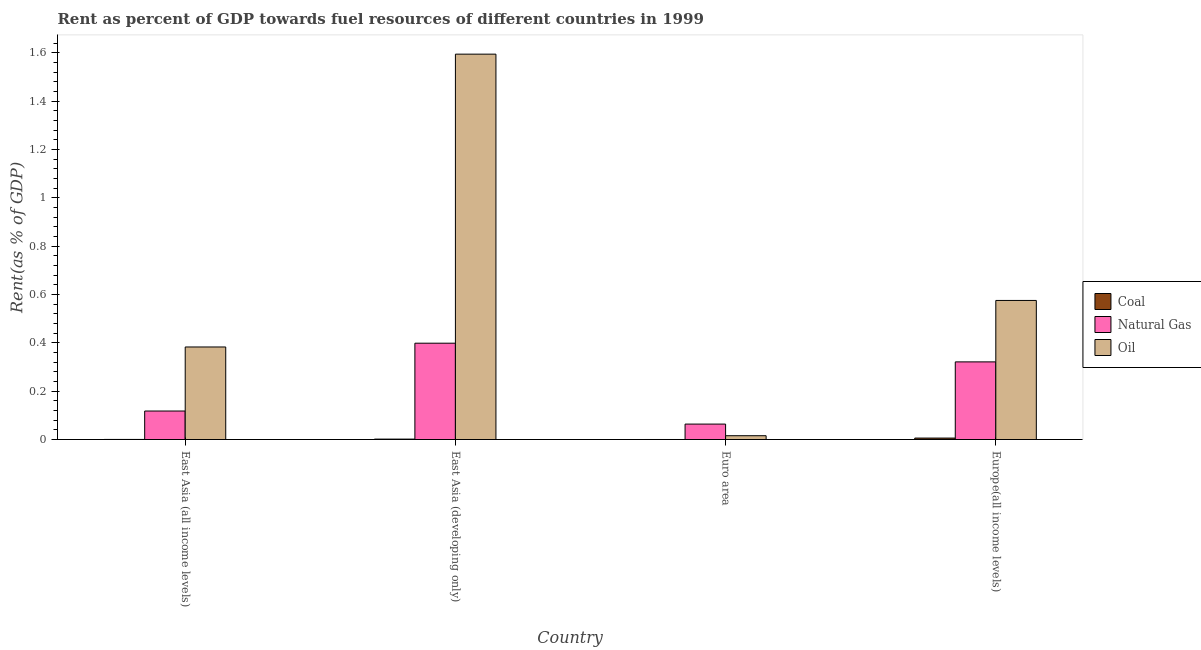How many different coloured bars are there?
Your answer should be compact. 3. How many groups of bars are there?
Your answer should be compact. 4. Are the number of bars per tick equal to the number of legend labels?
Your response must be concise. Yes. Are the number of bars on each tick of the X-axis equal?
Your answer should be very brief. Yes. How many bars are there on the 1st tick from the left?
Provide a short and direct response. 3. How many bars are there on the 3rd tick from the right?
Ensure brevity in your answer.  3. What is the label of the 2nd group of bars from the left?
Offer a terse response. East Asia (developing only). In how many cases, is the number of bars for a given country not equal to the number of legend labels?
Make the answer very short. 0. What is the rent towards oil in Europe(all income levels)?
Your answer should be very brief. 0.58. Across all countries, what is the maximum rent towards natural gas?
Your answer should be very brief. 0.4. Across all countries, what is the minimum rent towards natural gas?
Provide a succinct answer. 0.06. In which country was the rent towards coal maximum?
Keep it short and to the point. Europe(all income levels). In which country was the rent towards oil minimum?
Keep it short and to the point. Euro area. What is the total rent towards natural gas in the graph?
Offer a very short reply. 0.9. What is the difference between the rent towards oil in East Asia (developing only) and that in Euro area?
Your answer should be compact. 1.58. What is the difference between the rent towards coal in Euro area and the rent towards oil in East Asia (developing only)?
Make the answer very short. -1.59. What is the average rent towards oil per country?
Offer a terse response. 0.64. What is the difference between the rent towards natural gas and rent towards oil in East Asia (all income levels)?
Provide a succinct answer. -0.26. What is the ratio of the rent towards coal in East Asia (developing only) to that in Europe(all income levels)?
Offer a very short reply. 0.29. Is the rent towards natural gas in East Asia (developing only) less than that in Europe(all income levels)?
Ensure brevity in your answer.  No. Is the difference between the rent towards oil in Euro area and Europe(all income levels) greater than the difference between the rent towards coal in Euro area and Europe(all income levels)?
Provide a short and direct response. No. What is the difference between the highest and the second highest rent towards oil?
Your answer should be compact. 1.02. What is the difference between the highest and the lowest rent towards coal?
Your answer should be compact. 0.01. In how many countries, is the rent towards oil greater than the average rent towards oil taken over all countries?
Give a very brief answer. 1. Is the sum of the rent towards coal in East Asia (developing only) and Europe(all income levels) greater than the maximum rent towards oil across all countries?
Your response must be concise. No. What does the 1st bar from the left in Euro area represents?
Provide a short and direct response. Coal. What does the 1st bar from the right in Euro area represents?
Your answer should be very brief. Oil. Is it the case that in every country, the sum of the rent towards coal and rent towards natural gas is greater than the rent towards oil?
Your answer should be very brief. No. How many bars are there?
Your answer should be compact. 12. How many countries are there in the graph?
Offer a terse response. 4. Are the values on the major ticks of Y-axis written in scientific E-notation?
Your answer should be compact. No. Does the graph contain any zero values?
Your answer should be compact. No. Does the graph contain grids?
Give a very brief answer. No. Where does the legend appear in the graph?
Provide a short and direct response. Center right. How many legend labels are there?
Provide a short and direct response. 3. What is the title of the graph?
Offer a terse response. Rent as percent of GDP towards fuel resources of different countries in 1999. What is the label or title of the Y-axis?
Your response must be concise. Rent(as % of GDP). What is the Rent(as % of GDP) in Coal in East Asia (all income levels)?
Provide a succinct answer. 0. What is the Rent(as % of GDP) of Natural Gas in East Asia (all income levels)?
Offer a very short reply. 0.12. What is the Rent(as % of GDP) in Oil in East Asia (all income levels)?
Your response must be concise. 0.38. What is the Rent(as % of GDP) of Coal in East Asia (developing only)?
Your response must be concise. 0. What is the Rent(as % of GDP) in Natural Gas in East Asia (developing only)?
Your answer should be compact. 0.4. What is the Rent(as % of GDP) of Oil in East Asia (developing only)?
Ensure brevity in your answer.  1.59. What is the Rent(as % of GDP) in Coal in Euro area?
Your response must be concise. 0. What is the Rent(as % of GDP) in Natural Gas in Euro area?
Offer a terse response. 0.06. What is the Rent(as % of GDP) in Oil in Euro area?
Provide a short and direct response. 0.02. What is the Rent(as % of GDP) in Coal in Europe(all income levels)?
Provide a short and direct response. 0.01. What is the Rent(as % of GDP) in Natural Gas in Europe(all income levels)?
Provide a succinct answer. 0.32. What is the Rent(as % of GDP) in Oil in Europe(all income levels)?
Provide a short and direct response. 0.58. Across all countries, what is the maximum Rent(as % of GDP) of Coal?
Give a very brief answer. 0.01. Across all countries, what is the maximum Rent(as % of GDP) of Natural Gas?
Your response must be concise. 0.4. Across all countries, what is the maximum Rent(as % of GDP) in Oil?
Ensure brevity in your answer.  1.59. Across all countries, what is the minimum Rent(as % of GDP) in Coal?
Your answer should be compact. 0. Across all countries, what is the minimum Rent(as % of GDP) of Natural Gas?
Make the answer very short. 0.06. Across all countries, what is the minimum Rent(as % of GDP) of Oil?
Your answer should be very brief. 0.02. What is the total Rent(as % of GDP) in Coal in the graph?
Your answer should be very brief. 0.01. What is the total Rent(as % of GDP) in Natural Gas in the graph?
Your response must be concise. 0.9. What is the total Rent(as % of GDP) of Oil in the graph?
Provide a succinct answer. 2.57. What is the difference between the Rent(as % of GDP) in Coal in East Asia (all income levels) and that in East Asia (developing only)?
Provide a succinct answer. -0. What is the difference between the Rent(as % of GDP) of Natural Gas in East Asia (all income levels) and that in East Asia (developing only)?
Offer a very short reply. -0.28. What is the difference between the Rent(as % of GDP) in Oil in East Asia (all income levels) and that in East Asia (developing only)?
Your answer should be compact. -1.21. What is the difference between the Rent(as % of GDP) in Natural Gas in East Asia (all income levels) and that in Euro area?
Your response must be concise. 0.05. What is the difference between the Rent(as % of GDP) in Oil in East Asia (all income levels) and that in Euro area?
Offer a very short reply. 0.37. What is the difference between the Rent(as % of GDP) in Coal in East Asia (all income levels) and that in Europe(all income levels)?
Provide a succinct answer. -0.01. What is the difference between the Rent(as % of GDP) in Natural Gas in East Asia (all income levels) and that in Europe(all income levels)?
Provide a succinct answer. -0.2. What is the difference between the Rent(as % of GDP) in Oil in East Asia (all income levels) and that in Europe(all income levels)?
Offer a terse response. -0.19. What is the difference between the Rent(as % of GDP) in Coal in East Asia (developing only) and that in Euro area?
Your response must be concise. 0. What is the difference between the Rent(as % of GDP) of Natural Gas in East Asia (developing only) and that in Euro area?
Provide a succinct answer. 0.33. What is the difference between the Rent(as % of GDP) of Oil in East Asia (developing only) and that in Euro area?
Give a very brief answer. 1.58. What is the difference between the Rent(as % of GDP) of Coal in East Asia (developing only) and that in Europe(all income levels)?
Your response must be concise. -0. What is the difference between the Rent(as % of GDP) in Natural Gas in East Asia (developing only) and that in Europe(all income levels)?
Ensure brevity in your answer.  0.08. What is the difference between the Rent(as % of GDP) of Oil in East Asia (developing only) and that in Europe(all income levels)?
Your answer should be very brief. 1.02. What is the difference between the Rent(as % of GDP) of Coal in Euro area and that in Europe(all income levels)?
Provide a short and direct response. -0.01. What is the difference between the Rent(as % of GDP) of Natural Gas in Euro area and that in Europe(all income levels)?
Provide a short and direct response. -0.26. What is the difference between the Rent(as % of GDP) of Oil in Euro area and that in Europe(all income levels)?
Offer a very short reply. -0.56. What is the difference between the Rent(as % of GDP) of Coal in East Asia (all income levels) and the Rent(as % of GDP) of Natural Gas in East Asia (developing only)?
Offer a terse response. -0.4. What is the difference between the Rent(as % of GDP) in Coal in East Asia (all income levels) and the Rent(as % of GDP) in Oil in East Asia (developing only)?
Give a very brief answer. -1.59. What is the difference between the Rent(as % of GDP) of Natural Gas in East Asia (all income levels) and the Rent(as % of GDP) of Oil in East Asia (developing only)?
Keep it short and to the point. -1.48. What is the difference between the Rent(as % of GDP) of Coal in East Asia (all income levels) and the Rent(as % of GDP) of Natural Gas in Euro area?
Provide a short and direct response. -0.06. What is the difference between the Rent(as % of GDP) in Coal in East Asia (all income levels) and the Rent(as % of GDP) in Oil in Euro area?
Your response must be concise. -0.02. What is the difference between the Rent(as % of GDP) in Natural Gas in East Asia (all income levels) and the Rent(as % of GDP) in Oil in Euro area?
Give a very brief answer. 0.1. What is the difference between the Rent(as % of GDP) in Coal in East Asia (all income levels) and the Rent(as % of GDP) in Natural Gas in Europe(all income levels)?
Give a very brief answer. -0.32. What is the difference between the Rent(as % of GDP) in Coal in East Asia (all income levels) and the Rent(as % of GDP) in Oil in Europe(all income levels)?
Offer a terse response. -0.57. What is the difference between the Rent(as % of GDP) in Natural Gas in East Asia (all income levels) and the Rent(as % of GDP) in Oil in Europe(all income levels)?
Make the answer very short. -0.46. What is the difference between the Rent(as % of GDP) of Coal in East Asia (developing only) and the Rent(as % of GDP) of Natural Gas in Euro area?
Your answer should be compact. -0.06. What is the difference between the Rent(as % of GDP) of Coal in East Asia (developing only) and the Rent(as % of GDP) of Oil in Euro area?
Make the answer very short. -0.01. What is the difference between the Rent(as % of GDP) in Natural Gas in East Asia (developing only) and the Rent(as % of GDP) in Oil in Euro area?
Provide a succinct answer. 0.38. What is the difference between the Rent(as % of GDP) in Coal in East Asia (developing only) and the Rent(as % of GDP) in Natural Gas in Europe(all income levels)?
Make the answer very short. -0.32. What is the difference between the Rent(as % of GDP) in Coal in East Asia (developing only) and the Rent(as % of GDP) in Oil in Europe(all income levels)?
Provide a succinct answer. -0.57. What is the difference between the Rent(as % of GDP) of Natural Gas in East Asia (developing only) and the Rent(as % of GDP) of Oil in Europe(all income levels)?
Your response must be concise. -0.18. What is the difference between the Rent(as % of GDP) in Coal in Euro area and the Rent(as % of GDP) in Natural Gas in Europe(all income levels)?
Make the answer very short. -0.32. What is the difference between the Rent(as % of GDP) of Coal in Euro area and the Rent(as % of GDP) of Oil in Europe(all income levels)?
Your answer should be very brief. -0.58. What is the difference between the Rent(as % of GDP) of Natural Gas in Euro area and the Rent(as % of GDP) of Oil in Europe(all income levels)?
Ensure brevity in your answer.  -0.51. What is the average Rent(as % of GDP) in Coal per country?
Make the answer very short. 0. What is the average Rent(as % of GDP) of Natural Gas per country?
Your response must be concise. 0.23. What is the average Rent(as % of GDP) of Oil per country?
Provide a succinct answer. 0.64. What is the difference between the Rent(as % of GDP) of Coal and Rent(as % of GDP) of Natural Gas in East Asia (all income levels)?
Offer a terse response. -0.12. What is the difference between the Rent(as % of GDP) of Coal and Rent(as % of GDP) of Oil in East Asia (all income levels)?
Provide a short and direct response. -0.38. What is the difference between the Rent(as % of GDP) of Natural Gas and Rent(as % of GDP) of Oil in East Asia (all income levels)?
Provide a succinct answer. -0.27. What is the difference between the Rent(as % of GDP) of Coal and Rent(as % of GDP) of Natural Gas in East Asia (developing only)?
Give a very brief answer. -0.4. What is the difference between the Rent(as % of GDP) of Coal and Rent(as % of GDP) of Oil in East Asia (developing only)?
Provide a short and direct response. -1.59. What is the difference between the Rent(as % of GDP) in Natural Gas and Rent(as % of GDP) in Oil in East Asia (developing only)?
Offer a terse response. -1.2. What is the difference between the Rent(as % of GDP) of Coal and Rent(as % of GDP) of Natural Gas in Euro area?
Offer a terse response. -0.06. What is the difference between the Rent(as % of GDP) in Coal and Rent(as % of GDP) in Oil in Euro area?
Keep it short and to the point. -0.02. What is the difference between the Rent(as % of GDP) in Natural Gas and Rent(as % of GDP) in Oil in Euro area?
Offer a terse response. 0.05. What is the difference between the Rent(as % of GDP) of Coal and Rent(as % of GDP) of Natural Gas in Europe(all income levels)?
Provide a short and direct response. -0.32. What is the difference between the Rent(as % of GDP) of Coal and Rent(as % of GDP) of Oil in Europe(all income levels)?
Provide a succinct answer. -0.57. What is the difference between the Rent(as % of GDP) in Natural Gas and Rent(as % of GDP) in Oil in Europe(all income levels)?
Offer a terse response. -0.25. What is the ratio of the Rent(as % of GDP) in Coal in East Asia (all income levels) to that in East Asia (developing only)?
Keep it short and to the point. 0.21. What is the ratio of the Rent(as % of GDP) in Natural Gas in East Asia (all income levels) to that in East Asia (developing only)?
Your answer should be compact. 0.3. What is the ratio of the Rent(as % of GDP) in Oil in East Asia (all income levels) to that in East Asia (developing only)?
Offer a very short reply. 0.24. What is the ratio of the Rent(as % of GDP) of Coal in East Asia (all income levels) to that in Euro area?
Your answer should be compact. 3.41. What is the ratio of the Rent(as % of GDP) of Natural Gas in East Asia (all income levels) to that in Euro area?
Provide a short and direct response. 1.85. What is the ratio of the Rent(as % of GDP) in Oil in East Asia (all income levels) to that in Euro area?
Give a very brief answer. 24.32. What is the ratio of the Rent(as % of GDP) of Coal in East Asia (all income levels) to that in Europe(all income levels)?
Your answer should be compact. 0.06. What is the ratio of the Rent(as % of GDP) in Natural Gas in East Asia (all income levels) to that in Europe(all income levels)?
Offer a very short reply. 0.37. What is the ratio of the Rent(as % of GDP) of Oil in East Asia (all income levels) to that in Europe(all income levels)?
Make the answer very short. 0.67. What is the ratio of the Rent(as % of GDP) in Coal in East Asia (developing only) to that in Euro area?
Offer a very short reply. 16.4. What is the ratio of the Rent(as % of GDP) in Natural Gas in East Asia (developing only) to that in Euro area?
Ensure brevity in your answer.  6.24. What is the ratio of the Rent(as % of GDP) of Oil in East Asia (developing only) to that in Euro area?
Give a very brief answer. 101.26. What is the ratio of the Rent(as % of GDP) in Coal in East Asia (developing only) to that in Europe(all income levels)?
Provide a succinct answer. 0.29. What is the ratio of the Rent(as % of GDP) of Natural Gas in East Asia (developing only) to that in Europe(all income levels)?
Give a very brief answer. 1.24. What is the ratio of the Rent(as % of GDP) in Oil in East Asia (developing only) to that in Europe(all income levels)?
Provide a succinct answer. 2.77. What is the ratio of the Rent(as % of GDP) of Coal in Euro area to that in Europe(all income levels)?
Make the answer very short. 0.02. What is the ratio of the Rent(as % of GDP) of Natural Gas in Euro area to that in Europe(all income levels)?
Give a very brief answer. 0.2. What is the ratio of the Rent(as % of GDP) in Oil in Euro area to that in Europe(all income levels)?
Make the answer very short. 0.03. What is the difference between the highest and the second highest Rent(as % of GDP) of Coal?
Give a very brief answer. 0. What is the difference between the highest and the second highest Rent(as % of GDP) of Natural Gas?
Offer a very short reply. 0.08. What is the difference between the highest and the second highest Rent(as % of GDP) in Oil?
Make the answer very short. 1.02. What is the difference between the highest and the lowest Rent(as % of GDP) of Coal?
Provide a short and direct response. 0.01. What is the difference between the highest and the lowest Rent(as % of GDP) in Natural Gas?
Ensure brevity in your answer.  0.33. What is the difference between the highest and the lowest Rent(as % of GDP) in Oil?
Your answer should be very brief. 1.58. 